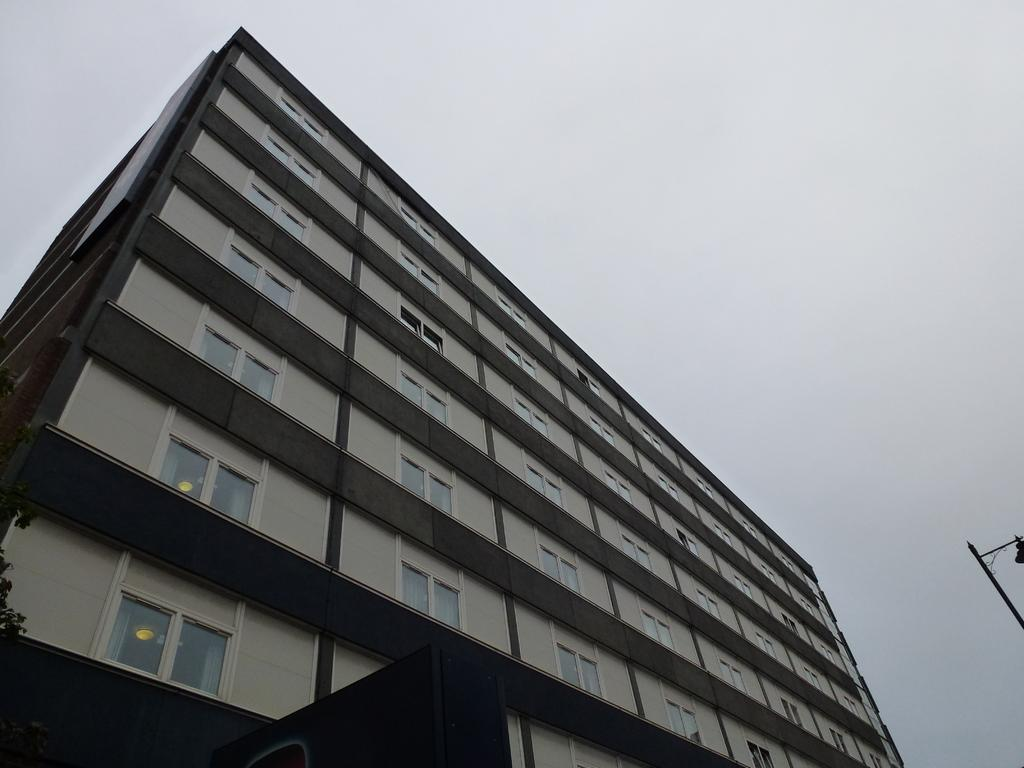What type of structure is visible in the image? There is a building in the image. Can you describe any other objects or features in the image? There is a pole on the right side of the image. What type of music is being played in the background of the image? There is no music present in the image, as it only features a building and a pole. 